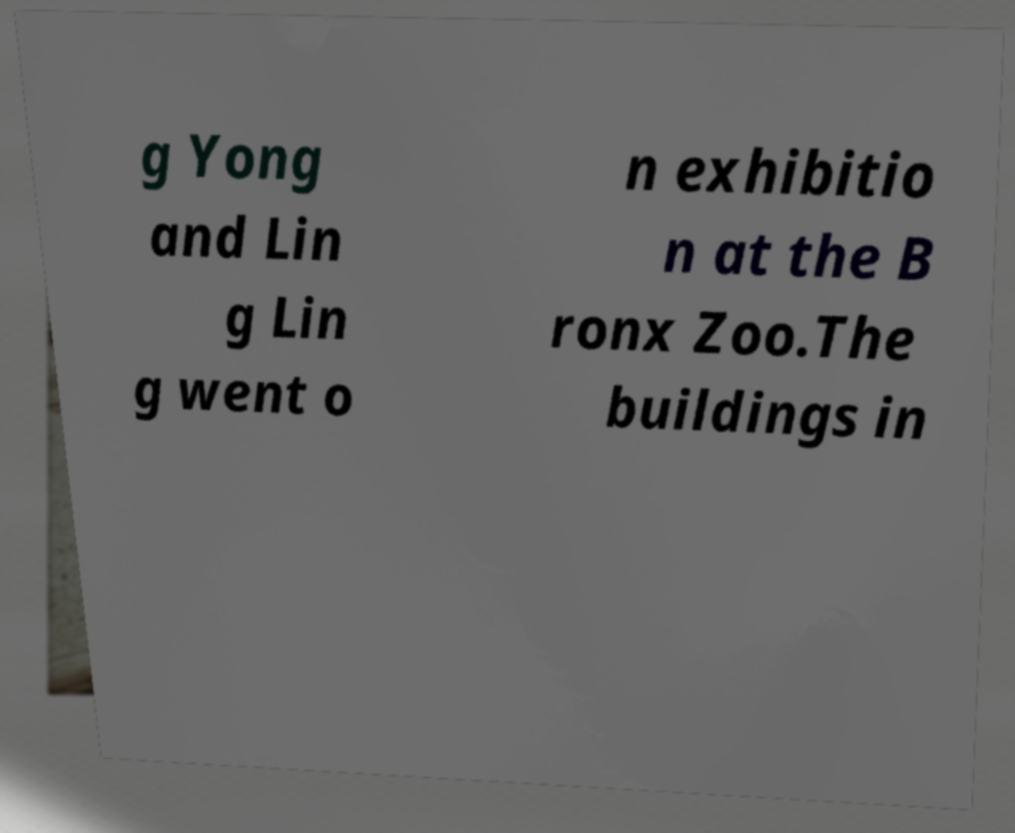What messages or text are displayed in this image? I need them in a readable, typed format. g Yong and Lin g Lin g went o n exhibitio n at the B ronx Zoo.The buildings in 